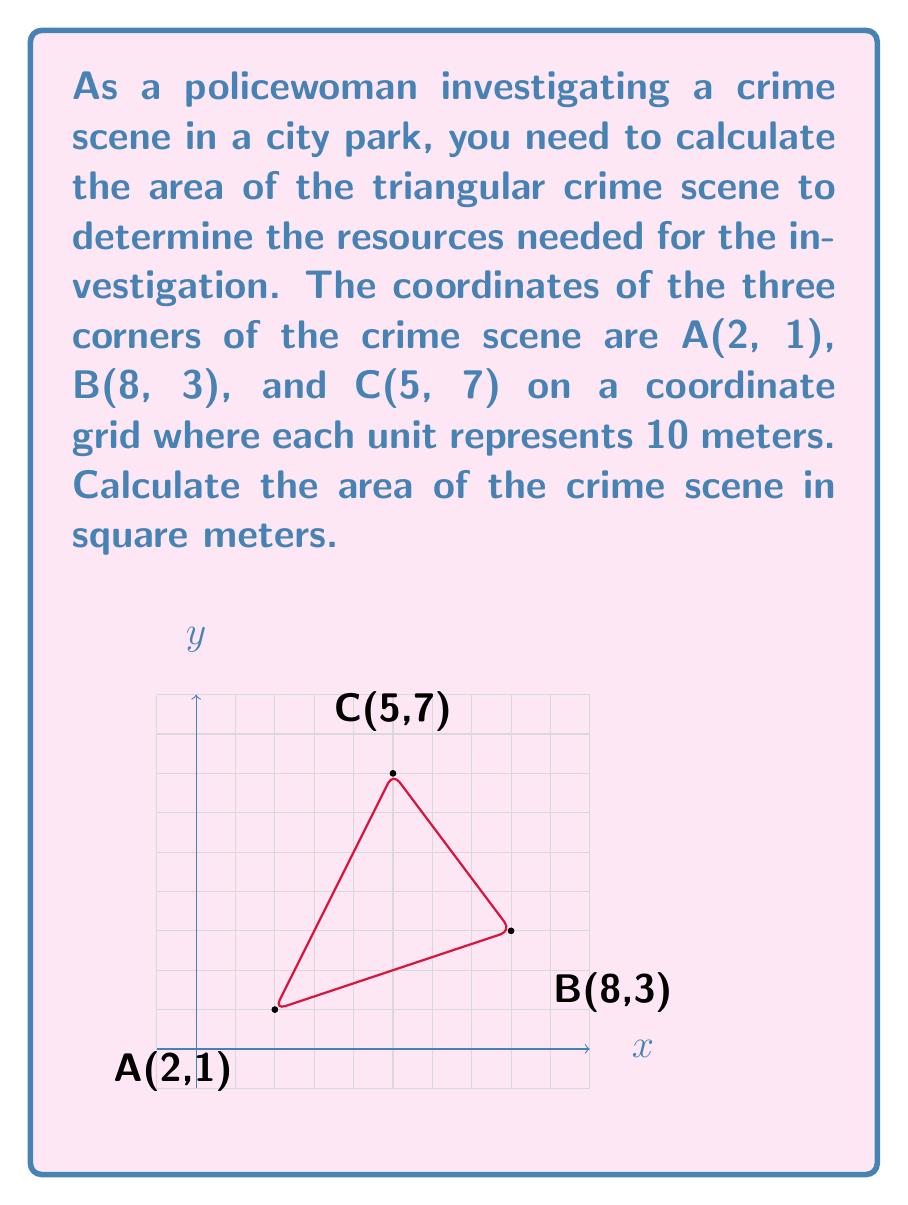Can you solve this math problem? To calculate the area of the triangular crime scene, we'll use the formula for the area of a triangle given the coordinates of its vertices:

$$ \text{Area} = \frac{1}{2}|x_1(y_2 - y_3) + x_2(y_3 - y_1) + x_3(y_1 - y_2)| $$

Where $(x_1, y_1)$, $(x_2, y_2)$, and $(x_3, y_3)$ are the coordinates of the three vertices.

Step 1: Identify the coordinates
A(2, 1), B(8, 3), C(5, 7)
$(x_1, y_1) = (2, 1)$
$(x_2, y_2) = (8, 3)$
$(x_3, y_3) = (5, 7)$

Step 2: Substitute the values into the formula
$$ \text{Area} = \frac{1}{2}|2(3 - 7) + 8(7 - 1) + 5(1 - 3)| $$

Step 3: Simplify the expression
$$ \text{Area} = \frac{1}{2}|2(-4) + 8(6) + 5(-2)| $$
$$ \text{Area} = \frac{1}{2}|-8 + 48 - 10| $$
$$ \text{Area} = \frac{1}{2}|30| $$
$$ \text{Area} = \frac{1}{2} \cdot 30 = 15 $$

Step 4: Convert the result to square meters
Since each unit represents 10 meters, we need to multiply the area by $10^2 = 100$:

$$ \text{Area in m}^2 = 15 \cdot 100 = 1500 $$

Therefore, the area of the crime scene is 1500 square meters.
Answer: 1500 m² 